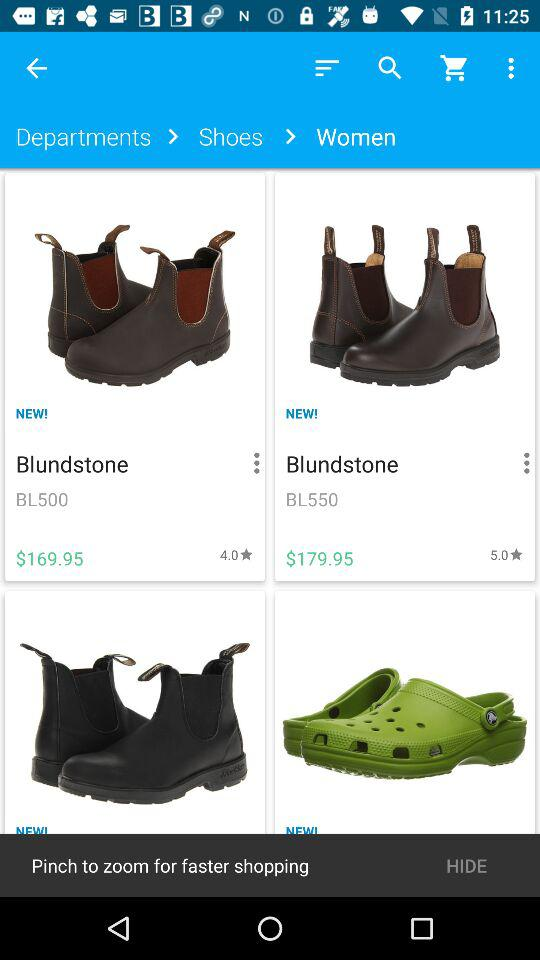How much more expensive is the second item than the first?
Answer the question using a single word or phrase. $10.00 